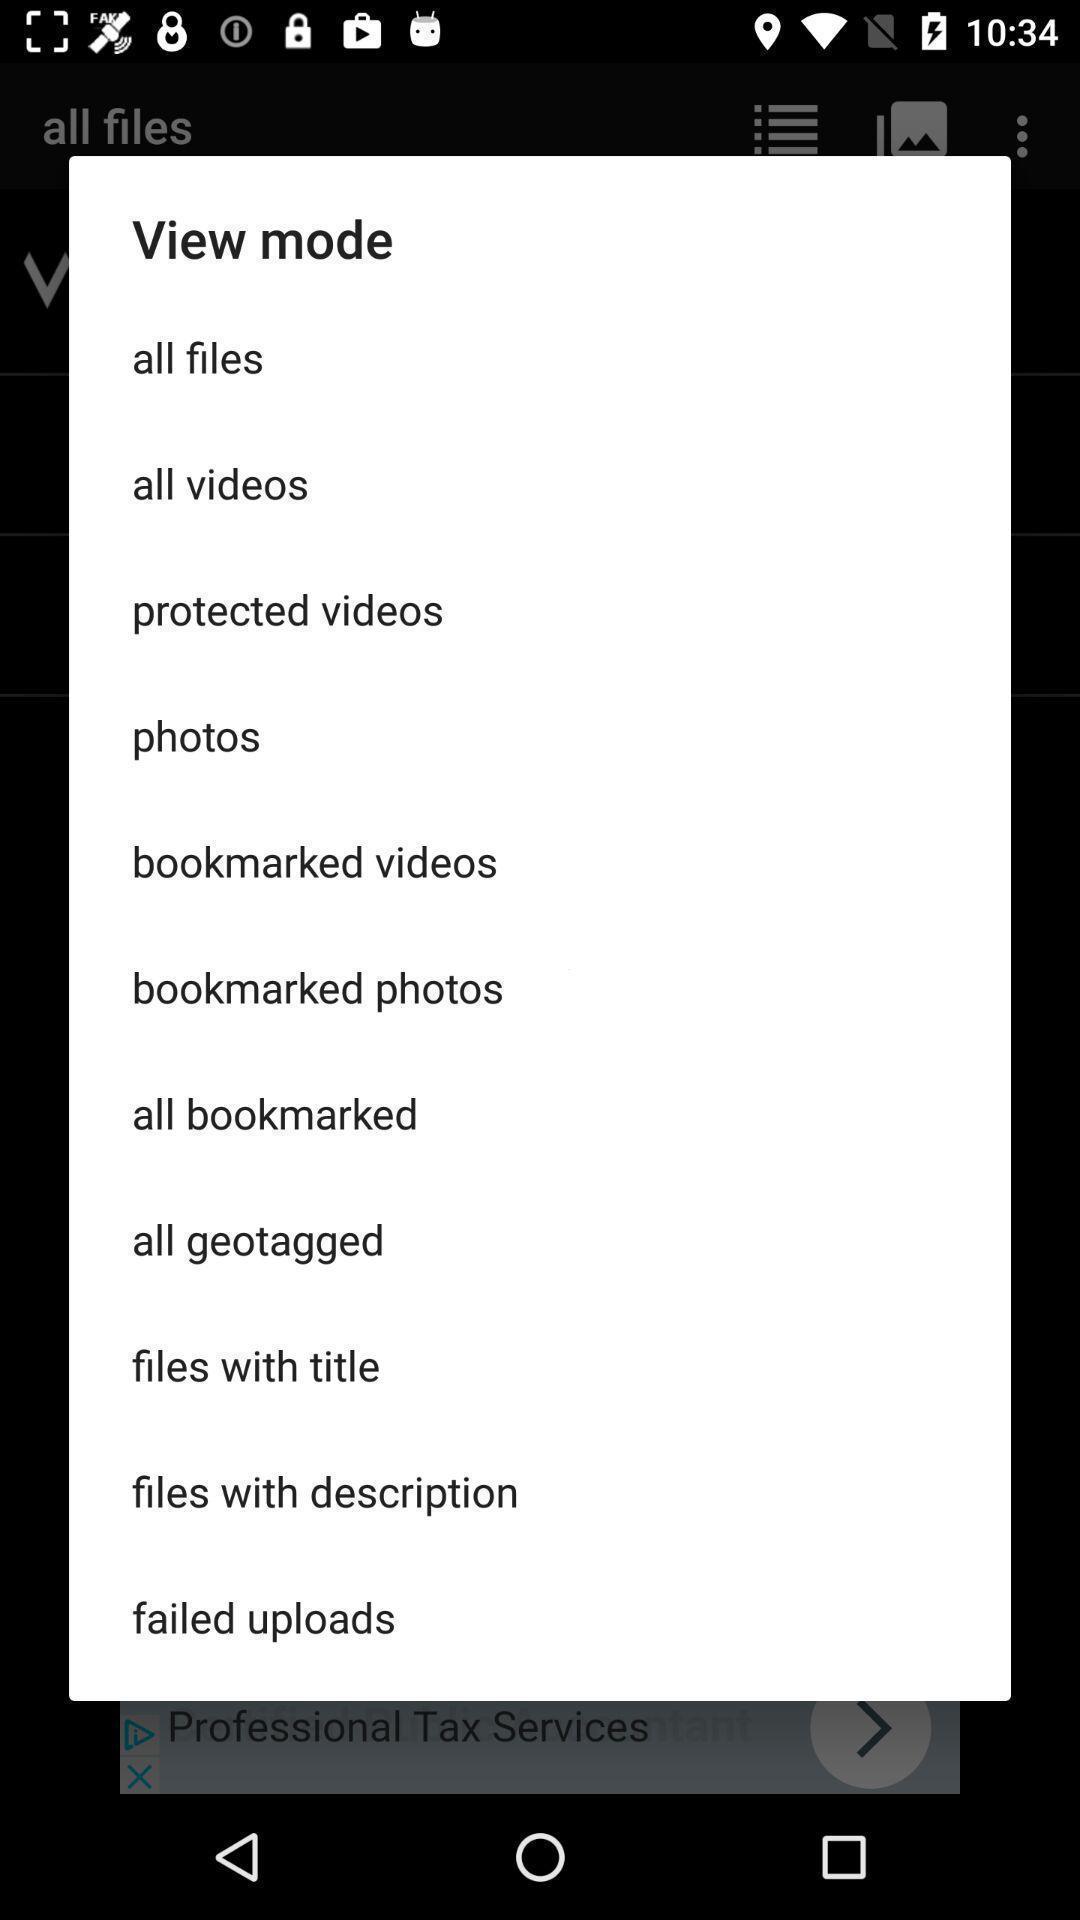What is the overall content of this screenshot? Pop-up showing all view mode of the multimedia. 